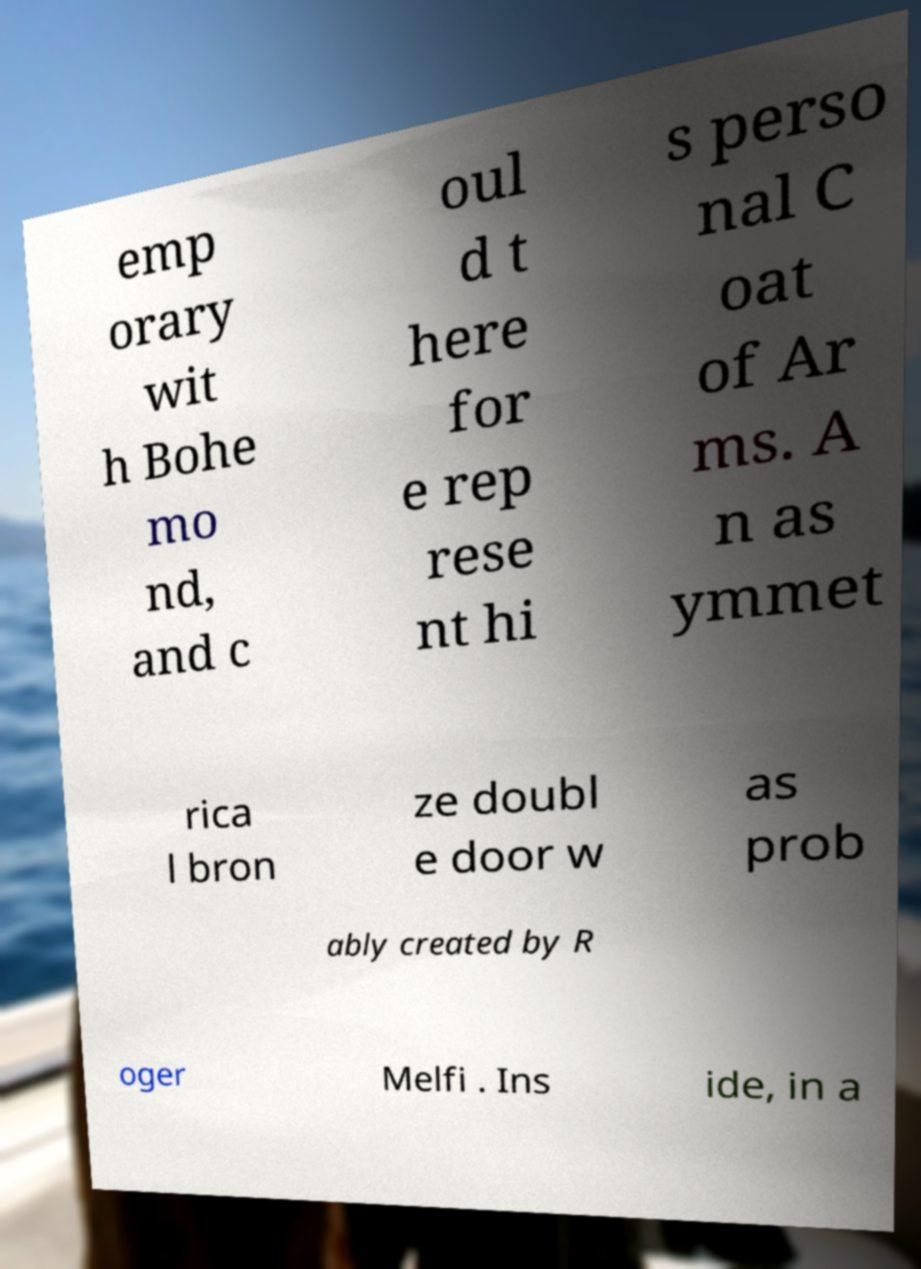Can you accurately transcribe the text from the provided image for me? emp orary wit h Bohe mo nd, and c oul d t here for e rep rese nt hi s perso nal C oat of Ar ms. A n as ymmet rica l bron ze doubl e door w as prob ably created by R oger Melfi . Ins ide, in a 